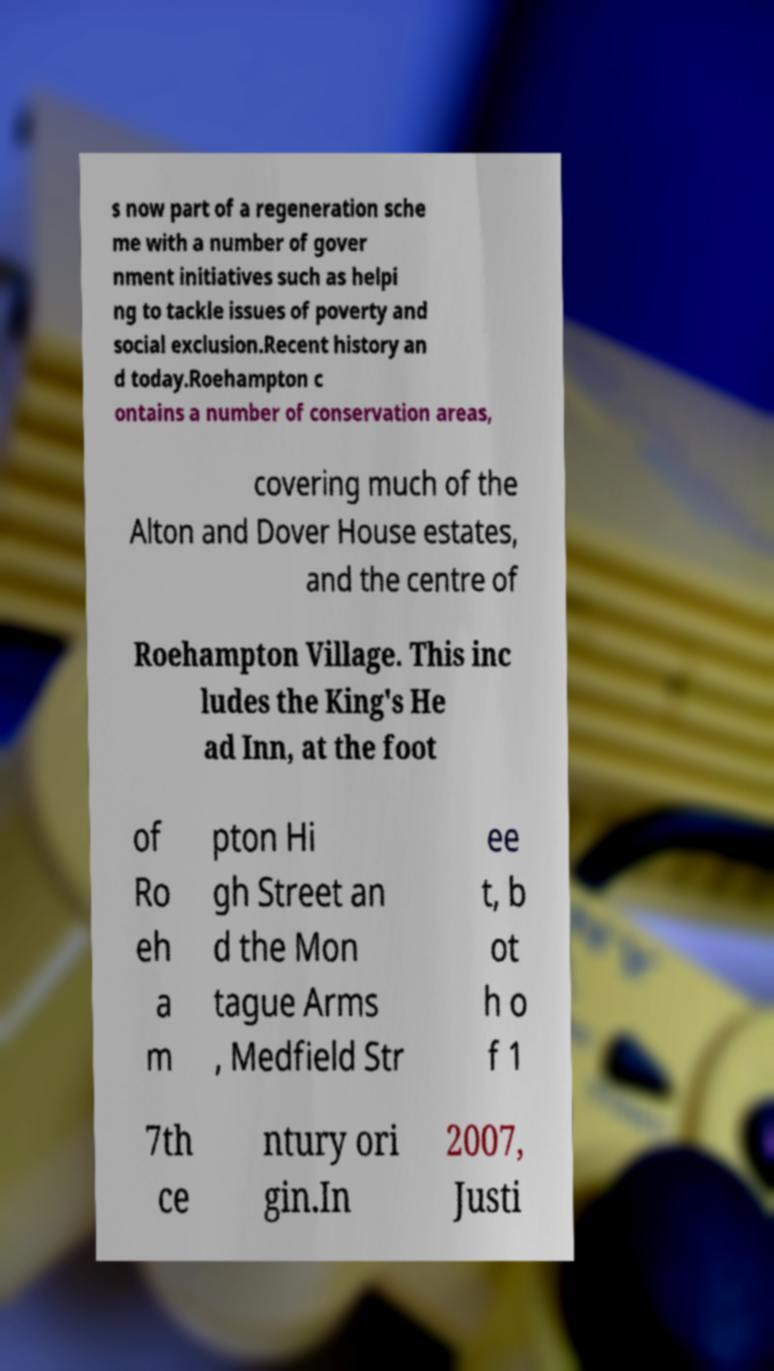What messages or text are displayed in this image? I need them in a readable, typed format. s now part of a regeneration sche me with a number of gover nment initiatives such as helpi ng to tackle issues of poverty and social exclusion.Recent history an d today.Roehampton c ontains a number of conservation areas, covering much of the Alton and Dover House estates, and the centre of Roehampton Village. This inc ludes the King's He ad Inn, at the foot of Ro eh a m pton Hi gh Street an d the Mon tague Arms , Medfield Str ee t, b ot h o f 1 7th ce ntury ori gin.In 2007, Justi 